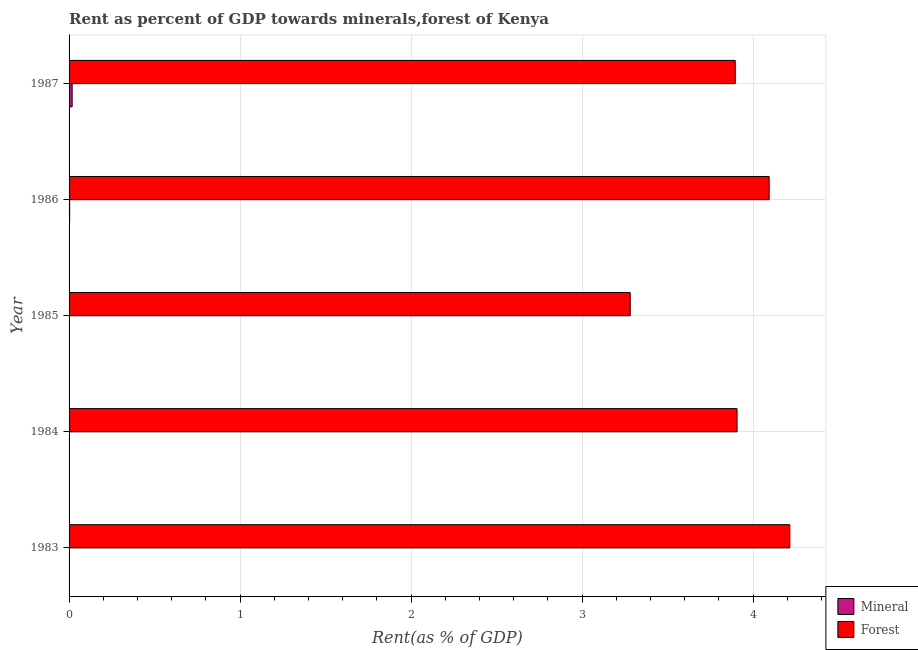Are the number of bars per tick equal to the number of legend labels?
Offer a terse response. Yes. How many bars are there on the 3rd tick from the top?
Keep it short and to the point. 2. How many bars are there on the 3rd tick from the bottom?
Give a very brief answer. 2. In how many cases, is the number of bars for a given year not equal to the number of legend labels?
Provide a succinct answer. 0. What is the mineral rent in 1987?
Your answer should be compact. 0.02. Across all years, what is the maximum forest rent?
Provide a succinct answer. 4.21. Across all years, what is the minimum mineral rent?
Your answer should be very brief. 0. In which year was the mineral rent minimum?
Provide a succinct answer. 1983. What is the total forest rent in the graph?
Your answer should be compact. 19.39. What is the difference between the forest rent in 1984 and that in 1986?
Provide a short and direct response. -0.19. What is the difference between the forest rent in 1983 and the mineral rent in 1987?
Ensure brevity in your answer.  4.2. What is the average mineral rent per year?
Provide a succinct answer. 0.01. In the year 1986, what is the difference between the forest rent and mineral rent?
Your answer should be very brief. 4.09. What is the ratio of the forest rent in 1984 to that in 1987?
Provide a succinct answer. 1. Is the mineral rent in 1985 less than that in 1987?
Offer a terse response. Yes. Is the difference between the forest rent in 1984 and 1985 greater than the difference between the mineral rent in 1984 and 1985?
Your answer should be very brief. Yes. What is the difference between the highest and the second highest forest rent?
Offer a terse response. 0.12. In how many years, is the forest rent greater than the average forest rent taken over all years?
Make the answer very short. 4. Is the sum of the mineral rent in 1984 and 1987 greater than the maximum forest rent across all years?
Offer a terse response. No. What does the 2nd bar from the top in 1987 represents?
Make the answer very short. Mineral. What does the 2nd bar from the bottom in 1983 represents?
Your response must be concise. Forest. How many bars are there?
Offer a terse response. 10. Are all the bars in the graph horizontal?
Your answer should be compact. Yes. Does the graph contain grids?
Your answer should be very brief. Yes. What is the title of the graph?
Offer a very short reply. Rent as percent of GDP towards minerals,forest of Kenya. What is the label or title of the X-axis?
Your answer should be compact. Rent(as % of GDP). What is the Rent(as % of GDP) of Mineral in 1983?
Your response must be concise. 0. What is the Rent(as % of GDP) in Forest in 1983?
Provide a succinct answer. 4.21. What is the Rent(as % of GDP) of Mineral in 1984?
Your answer should be compact. 0. What is the Rent(as % of GDP) of Forest in 1984?
Ensure brevity in your answer.  3.91. What is the Rent(as % of GDP) in Mineral in 1985?
Provide a short and direct response. 0. What is the Rent(as % of GDP) of Forest in 1985?
Offer a very short reply. 3.28. What is the Rent(as % of GDP) in Mineral in 1986?
Your answer should be compact. 0. What is the Rent(as % of GDP) in Forest in 1986?
Your answer should be compact. 4.09. What is the Rent(as % of GDP) in Mineral in 1987?
Your answer should be very brief. 0.02. What is the Rent(as % of GDP) of Forest in 1987?
Ensure brevity in your answer.  3.9. Across all years, what is the maximum Rent(as % of GDP) in Mineral?
Offer a terse response. 0.02. Across all years, what is the maximum Rent(as % of GDP) of Forest?
Provide a succinct answer. 4.21. Across all years, what is the minimum Rent(as % of GDP) of Mineral?
Your response must be concise. 0. Across all years, what is the minimum Rent(as % of GDP) in Forest?
Provide a short and direct response. 3.28. What is the total Rent(as % of GDP) of Mineral in the graph?
Keep it short and to the point. 0.02. What is the total Rent(as % of GDP) in Forest in the graph?
Provide a short and direct response. 19.39. What is the difference between the Rent(as % of GDP) in Mineral in 1983 and that in 1984?
Provide a short and direct response. -0. What is the difference between the Rent(as % of GDP) in Forest in 1983 and that in 1984?
Make the answer very short. 0.31. What is the difference between the Rent(as % of GDP) in Mineral in 1983 and that in 1985?
Provide a short and direct response. -0. What is the difference between the Rent(as % of GDP) in Forest in 1983 and that in 1985?
Your answer should be very brief. 0.93. What is the difference between the Rent(as % of GDP) of Mineral in 1983 and that in 1986?
Provide a succinct answer. -0. What is the difference between the Rent(as % of GDP) of Forest in 1983 and that in 1986?
Provide a short and direct response. 0.12. What is the difference between the Rent(as % of GDP) in Mineral in 1983 and that in 1987?
Your answer should be very brief. -0.02. What is the difference between the Rent(as % of GDP) of Forest in 1983 and that in 1987?
Your response must be concise. 0.32. What is the difference between the Rent(as % of GDP) of Mineral in 1984 and that in 1985?
Keep it short and to the point. 0. What is the difference between the Rent(as % of GDP) in Forest in 1984 and that in 1985?
Offer a terse response. 0.62. What is the difference between the Rent(as % of GDP) of Mineral in 1984 and that in 1986?
Offer a terse response. -0. What is the difference between the Rent(as % of GDP) of Forest in 1984 and that in 1986?
Your response must be concise. -0.19. What is the difference between the Rent(as % of GDP) of Mineral in 1984 and that in 1987?
Your answer should be very brief. -0.02. What is the difference between the Rent(as % of GDP) of Forest in 1984 and that in 1987?
Make the answer very short. 0.01. What is the difference between the Rent(as % of GDP) in Mineral in 1985 and that in 1986?
Offer a terse response. -0. What is the difference between the Rent(as % of GDP) of Forest in 1985 and that in 1986?
Offer a terse response. -0.81. What is the difference between the Rent(as % of GDP) of Mineral in 1985 and that in 1987?
Ensure brevity in your answer.  -0.02. What is the difference between the Rent(as % of GDP) of Forest in 1985 and that in 1987?
Your answer should be very brief. -0.61. What is the difference between the Rent(as % of GDP) in Mineral in 1986 and that in 1987?
Ensure brevity in your answer.  -0.01. What is the difference between the Rent(as % of GDP) in Forest in 1986 and that in 1987?
Provide a succinct answer. 0.2. What is the difference between the Rent(as % of GDP) in Mineral in 1983 and the Rent(as % of GDP) in Forest in 1984?
Give a very brief answer. -3.91. What is the difference between the Rent(as % of GDP) in Mineral in 1983 and the Rent(as % of GDP) in Forest in 1985?
Ensure brevity in your answer.  -3.28. What is the difference between the Rent(as % of GDP) of Mineral in 1983 and the Rent(as % of GDP) of Forest in 1986?
Provide a short and direct response. -4.09. What is the difference between the Rent(as % of GDP) of Mineral in 1983 and the Rent(as % of GDP) of Forest in 1987?
Make the answer very short. -3.9. What is the difference between the Rent(as % of GDP) of Mineral in 1984 and the Rent(as % of GDP) of Forest in 1985?
Offer a terse response. -3.28. What is the difference between the Rent(as % of GDP) in Mineral in 1984 and the Rent(as % of GDP) in Forest in 1986?
Keep it short and to the point. -4.09. What is the difference between the Rent(as % of GDP) in Mineral in 1984 and the Rent(as % of GDP) in Forest in 1987?
Your response must be concise. -3.89. What is the difference between the Rent(as % of GDP) of Mineral in 1985 and the Rent(as % of GDP) of Forest in 1986?
Offer a terse response. -4.09. What is the difference between the Rent(as % of GDP) in Mineral in 1985 and the Rent(as % of GDP) in Forest in 1987?
Your answer should be very brief. -3.89. What is the difference between the Rent(as % of GDP) of Mineral in 1986 and the Rent(as % of GDP) of Forest in 1987?
Your answer should be compact. -3.89. What is the average Rent(as % of GDP) in Mineral per year?
Your response must be concise. 0. What is the average Rent(as % of GDP) in Forest per year?
Offer a terse response. 3.88. In the year 1983, what is the difference between the Rent(as % of GDP) of Mineral and Rent(as % of GDP) of Forest?
Provide a short and direct response. -4.21. In the year 1984, what is the difference between the Rent(as % of GDP) of Mineral and Rent(as % of GDP) of Forest?
Provide a short and direct response. -3.9. In the year 1985, what is the difference between the Rent(as % of GDP) in Mineral and Rent(as % of GDP) in Forest?
Give a very brief answer. -3.28. In the year 1986, what is the difference between the Rent(as % of GDP) of Mineral and Rent(as % of GDP) of Forest?
Your answer should be compact. -4.09. In the year 1987, what is the difference between the Rent(as % of GDP) of Mineral and Rent(as % of GDP) of Forest?
Make the answer very short. -3.88. What is the ratio of the Rent(as % of GDP) in Mineral in 1983 to that in 1984?
Your response must be concise. 0.23. What is the ratio of the Rent(as % of GDP) of Forest in 1983 to that in 1984?
Make the answer very short. 1.08. What is the ratio of the Rent(as % of GDP) in Mineral in 1983 to that in 1985?
Make the answer very short. 0.46. What is the ratio of the Rent(as % of GDP) in Forest in 1983 to that in 1985?
Provide a succinct answer. 1.28. What is the ratio of the Rent(as % of GDP) in Mineral in 1983 to that in 1986?
Your answer should be compact. 0.09. What is the ratio of the Rent(as % of GDP) of Forest in 1983 to that in 1986?
Ensure brevity in your answer.  1.03. What is the ratio of the Rent(as % of GDP) in Mineral in 1983 to that in 1987?
Your answer should be compact. 0.02. What is the ratio of the Rent(as % of GDP) of Forest in 1983 to that in 1987?
Provide a succinct answer. 1.08. What is the ratio of the Rent(as % of GDP) of Mineral in 1984 to that in 1985?
Offer a very short reply. 1.94. What is the ratio of the Rent(as % of GDP) of Forest in 1984 to that in 1985?
Offer a terse response. 1.19. What is the ratio of the Rent(as % of GDP) of Mineral in 1984 to that in 1986?
Offer a very short reply. 0.37. What is the ratio of the Rent(as % of GDP) in Forest in 1984 to that in 1986?
Provide a short and direct response. 0.95. What is the ratio of the Rent(as % of GDP) in Mineral in 1984 to that in 1987?
Make the answer very short. 0.07. What is the ratio of the Rent(as % of GDP) in Mineral in 1985 to that in 1986?
Ensure brevity in your answer.  0.19. What is the ratio of the Rent(as % of GDP) of Forest in 1985 to that in 1986?
Keep it short and to the point. 0.8. What is the ratio of the Rent(as % of GDP) of Mineral in 1985 to that in 1987?
Ensure brevity in your answer.  0.04. What is the ratio of the Rent(as % of GDP) in Forest in 1985 to that in 1987?
Offer a very short reply. 0.84. What is the ratio of the Rent(as % of GDP) in Mineral in 1986 to that in 1987?
Provide a short and direct response. 0.19. What is the ratio of the Rent(as % of GDP) of Forest in 1986 to that in 1987?
Your answer should be very brief. 1.05. What is the difference between the highest and the second highest Rent(as % of GDP) of Mineral?
Give a very brief answer. 0.01. What is the difference between the highest and the second highest Rent(as % of GDP) in Forest?
Give a very brief answer. 0.12. What is the difference between the highest and the lowest Rent(as % of GDP) of Mineral?
Provide a short and direct response. 0.02. What is the difference between the highest and the lowest Rent(as % of GDP) in Forest?
Provide a succinct answer. 0.93. 